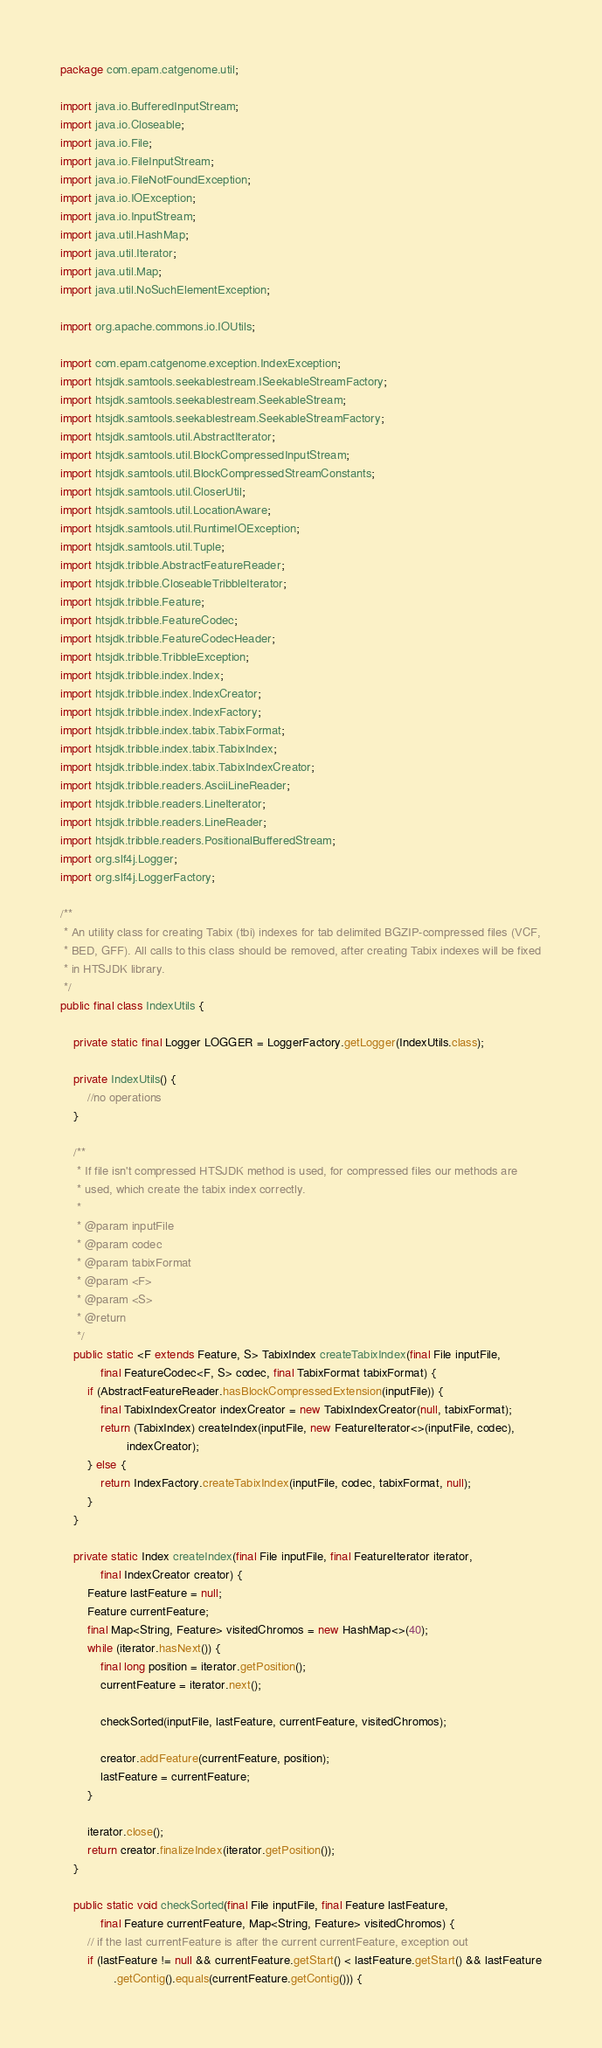<code> <loc_0><loc_0><loc_500><loc_500><_Java_>package com.epam.catgenome.util;

import java.io.BufferedInputStream;
import java.io.Closeable;
import java.io.File;
import java.io.FileInputStream;
import java.io.FileNotFoundException;
import java.io.IOException;
import java.io.InputStream;
import java.util.HashMap;
import java.util.Iterator;
import java.util.Map;
import java.util.NoSuchElementException;

import org.apache.commons.io.IOUtils;

import com.epam.catgenome.exception.IndexException;
import htsjdk.samtools.seekablestream.ISeekableStreamFactory;
import htsjdk.samtools.seekablestream.SeekableStream;
import htsjdk.samtools.seekablestream.SeekableStreamFactory;
import htsjdk.samtools.util.AbstractIterator;
import htsjdk.samtools.util.BlockCompressedInputStream;
import htsjdk.samtools.util.BlockCompressedStreamConstants;
import htsjdk.samtools.util.CloserUtil;
import htsjdk.samtools.util.LocationAware;
import htsjdk.samtools.util.RuntimeIOException;
import htsjdk.samtools.util.Tuple;
import htsjdk.tribble.AbstractFeatureReader;
import htsjdk.tribble.CloseableTribbleIterator;
import htsjdk.tribble.Feature;
import htsjdk.tribble.FeatureCodec;
import htsjdk.tribble.FeatureCodecHeader;
import htsjdk.tribble.TribbleException;
import htsjdk.tribble.index.Index;
import htsjdk.tribble.index.IndexCreator;
import htsjdk.tribble.index.IndexFactory;
import htsjdk.tribble.index.tabix.TabixFormat;
import htsjdk.tribble.index.tabix.TabixIndex;
import htsjdk.tribble.index.tabix.TabixIndexCreator;
import htsjdk.tribble.readers.AsciiLineReader;
import htsjdk.tribble.readers.LineIterator;
import htsjdk.tribble.readers.LineReader;
import htsjdk.tribble.readers.PositionalBufferedStream;
import org.slf4j.Logger;
import org.slf4j.LoggerFactory;

/**
 * An utility class for creating Tabix (tbi) indexes for tab delimited BGZIP-compressed files (VCF,
 * BED, GFF). All calls to this class should be removed, after creating Tabix indexes will be fixed
 * in HTSJDK library.
 */
public final class IndexUtils {

    private static final Logger LOGGER = LoggerFactory.getLogger(IndexUtils.class);

    private IndexUtils() {
        //no operations
    }

    /**
     * If file isn't compressed HTSJDK method is used, for compressed files our methods are
     * used, which create the tabix index correctly.
     *
     * @param inputFile
     * @param codec
     * @param tabixFormat
     * @param <F>
     * @param <S>
     * @return
     */
    public static <F extends Feature, S> TabixIndex createTabixIndex(final File inputFile,
            final FeatureCodec<F, S> codec, final TabixFormat tabixFormat) {
        if (AbstractFeatureReader.hasBlockCompressedExtension(inputFile)) {
            final TabixIndexCreator indexCreator = new TabixIndexCreator(null, tabixFormat);
            return (TabixIndex) createIndex(inputFile, new FeatureIterator<>(inputFile, codec),
                    indexCreator);
        } else {
            return IndexFactory.createTabixIndex(inputFile, codec, tabixFormat, null);
        }
    }

    private static Index createIndex(final File inputFile, final FeatureIterator iterator,
            final IndexCreator creator) {
        Feature lastFeature = null;
        Feature currentFeature;
        final Map<String, Feature> visitedChromos = new HashMap<>(40);
        while (iterator.hasNext()) {
            final long position = iterator.getPosition();
            currentFeature = iterator.next();

            checkSorted(inputFile, lastFeature, currentFeature, visitedChromos);

            creator.addFeature(currentFeature, position);
            lastFeature = currentFeature;
        }

        iterator.close();
        return creator.finalizeIndex(iterator.getPosition());
    }

    public static void checkSorted(final File inputFile, final Feature lastFeature,
            final Feature currentFeature, Map<String, Feature> visitedChromos) {
        // if the last currentFeature is after the current currentFeature, exception out
        if (lastFeature != null && currentFeature.getStart() < lastFeature.getStart() && lastFeature
                .getContig().equals(currentFeature.getContig())) {</code> 